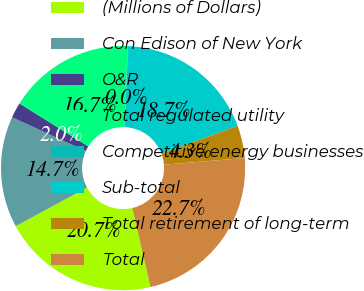Convert chart to OTSL. <chart><loc_0><loc_0><loc_500><loc_500><pie_chart><fcel>(Millions of Dollars)<fcel>Con Edison of New York<fcel>O&R<fcel>Total regulated utility<fcel>Competitive energy businesses<fcel>Sub-total<fcel>Total retirement of long-term<fcel>Total<nl><fcel>20.71%<fcel>14.73%<fcel>2.05%<fcel>16.72%<fcel>0.05%<fcel>18.72%<fcel>4.32%<fcel>22.71%<nl></chart> 